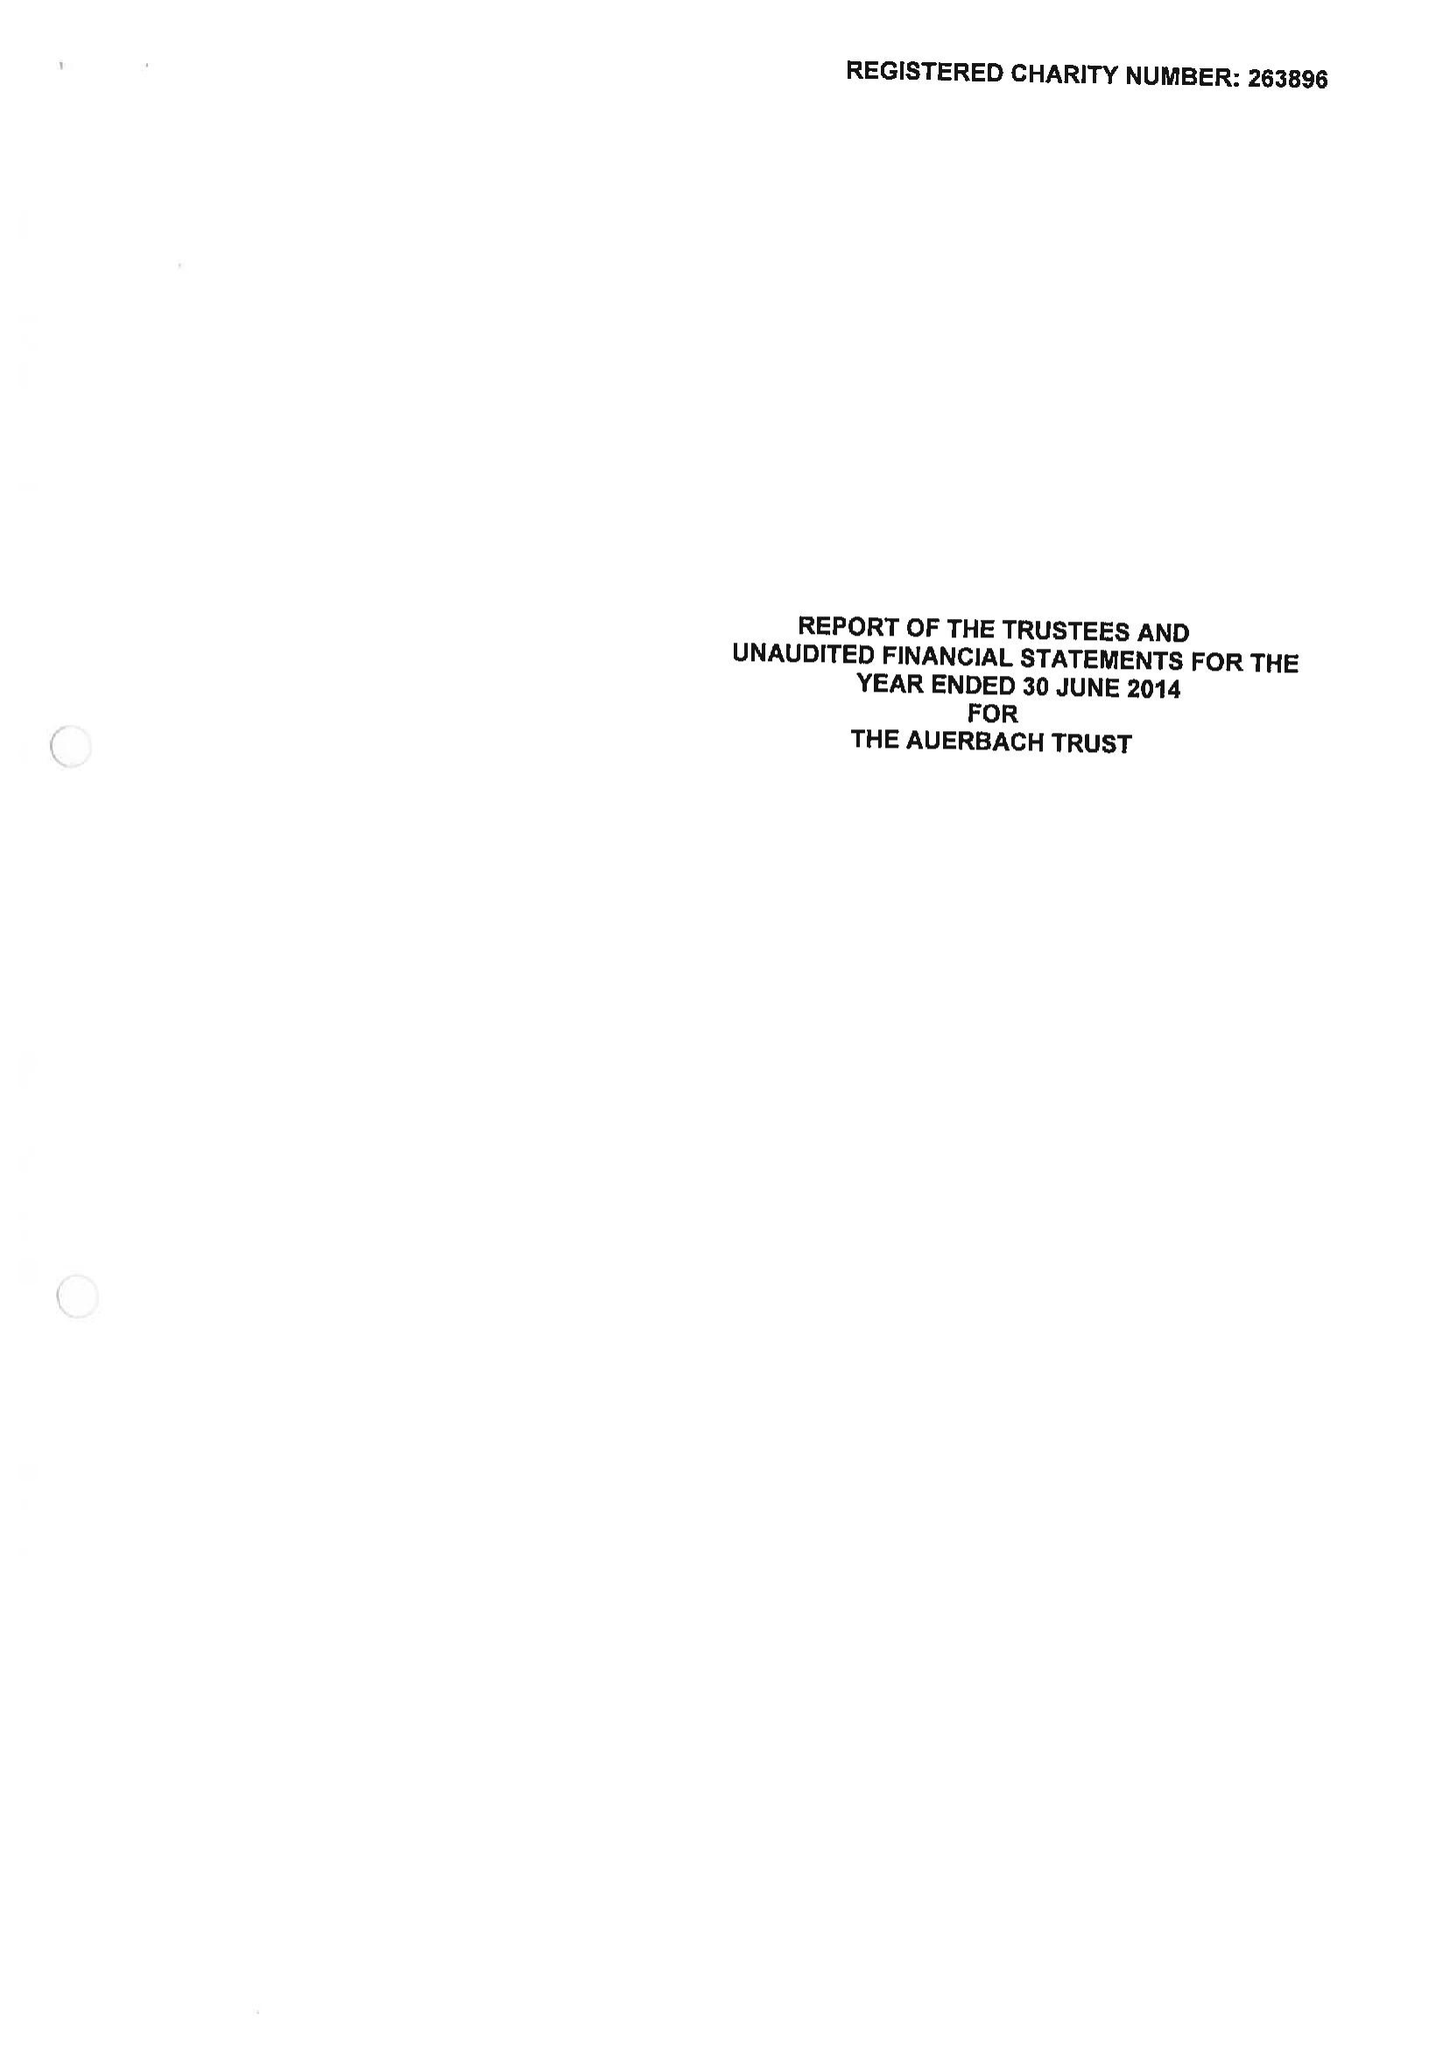What is the value for the report_date?
Answer the question using a single word or phrase. 2014-06-30 